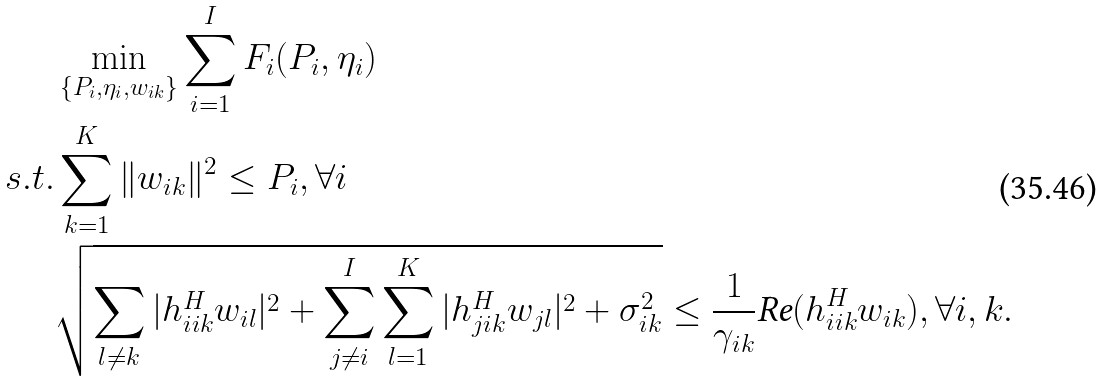<formula> <loc_0><loc_0><loc_500><loc_500>& \min _ { \{ P _ { i } , \eta _ { i } , w _ { i k } \} } \sum _ { i = 1 } ^ { I } F _ { i } ( P _ { i } , \eta _ { i } ) \\ s . t . & \sum _ { k = 1 } ^ { K } \| w _ { i k } \| ^ { 2 } \leq P _ { i } , \forall i \\ & \sqrt { \sum _ { l \neq k } | h _ { i i k } ^ { H } w _ { i l } | ^ { 2 } + \sum _ { j \neq i } ^ { I } \sum _ { l = 1 } ^ { K } { | h _ { j i k } ^ { H } w _ { j l } } | ^ { 2 } + \sigma _ { i k } ^ { 2 } } \leq \frac { 1 } { \gamma _ { i k } } \text {Re} ( h _ { i i k } ^ { H } w _ { i k } ) , \forall i , k .</formula> 